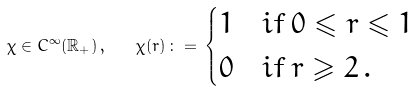Convert formula to latex. <formula><loc_0><loc_0><loc_500><loc_500>\chi \in C ^ { \infty } ( \mathbb { R } _ { + } ) \, , \quad \chi ( r ) \, \colon = \, \begin{cases} 1 & i f \, 0 \leqslant r \leqslant 1 \\ 0 & i f \, r \geqslant 2 \, . \end{cases}</formula> 